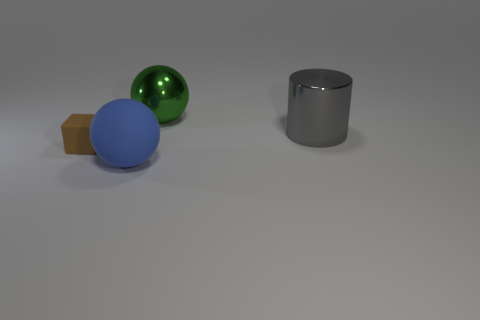What number of gray things are tiny blocks or large metal spheres?
Give a very brief answer. 0. How many other objects are there of the same shape as the brown thing?
Offer a very short reply. 0. There is a object that is both behind the large matte ball and on the left side of the large green metal object; what shape is it?
Offer a very short reply. Cube. Are there any big cylinders left of the gray metal object?
Provide a succinct answer. No. There is a green object that is the same shape as the blue rubber object; what is its size?
Offer a terse response. Large. Are there any other things that have the same size as the brown matte block?
Ensure brevity in your answer.  No. Does the big gray metallic thing have the same shape as the small matte thing?
Your answer should be very brief. No. There is a sphere that is behind the rubber cube that is to the left of the big matte object; how big is it?
Your response must be concise. Large. What is the color of the other big thing that is the same shape as the green object?
Give a very brief answer. Blue. The brown block has what size?
Keep it short and to the point. Small. 